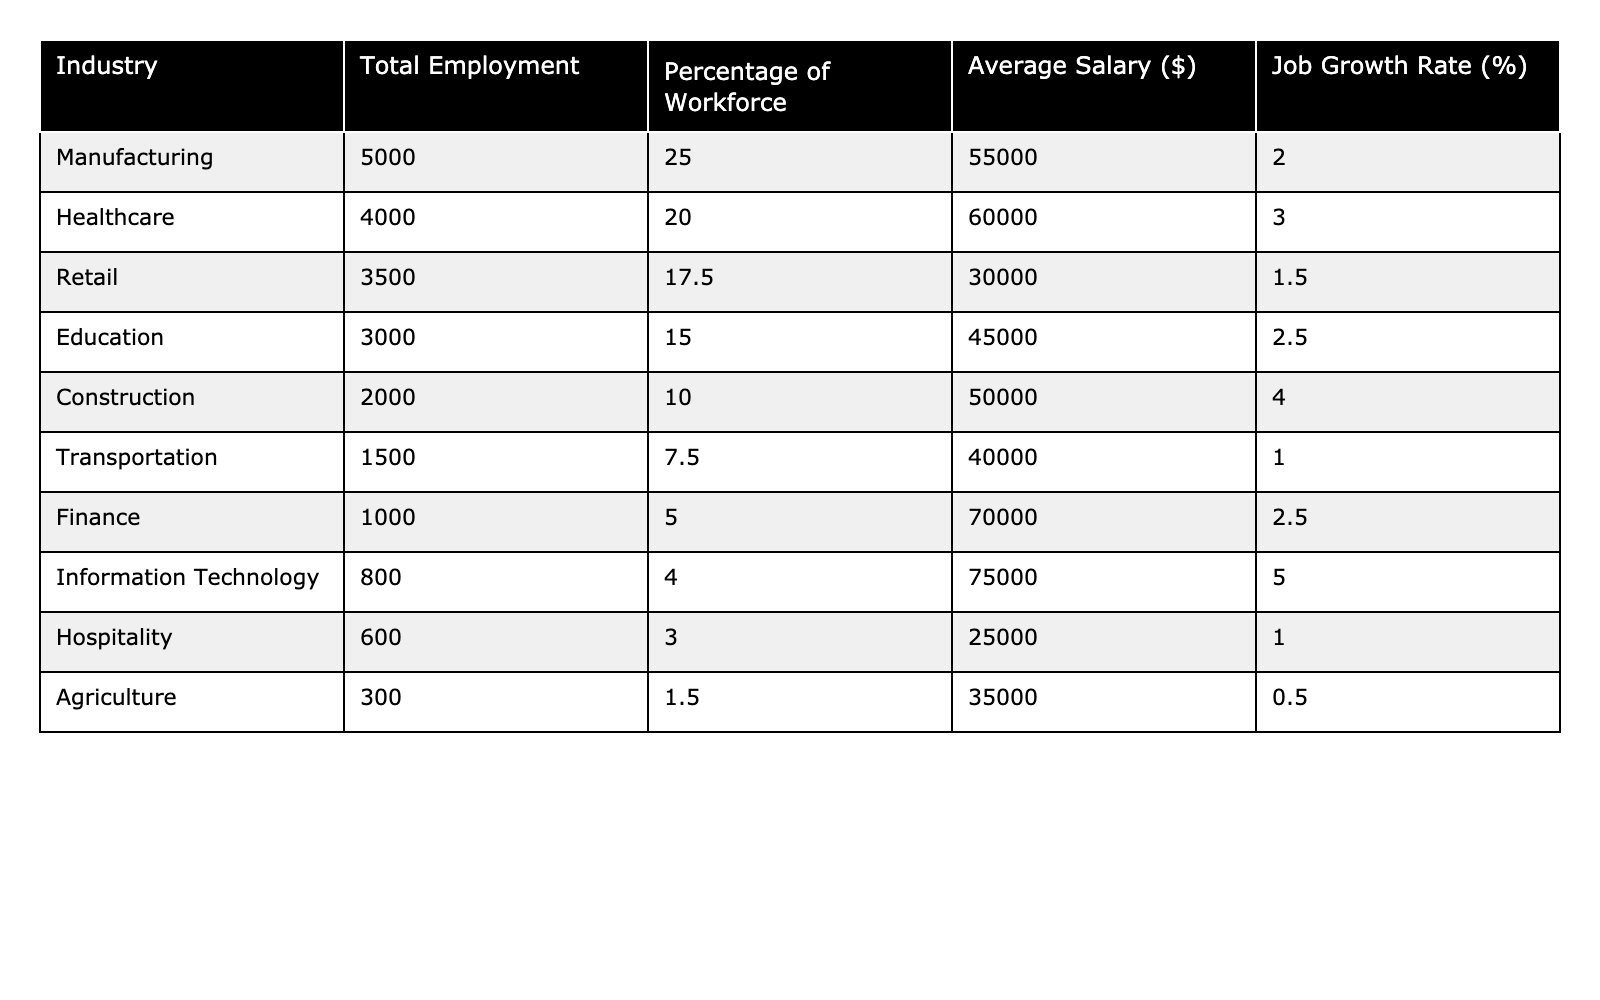What's the total employment in the Manufacturing industry? The table lists the Total Employment for the Manufacturing industry as 5,000.
Answer: 5000 Which industry has the highest average salary? The highest average salary in the table is $75,000, associated with the Information Technology industry.
Answer: Information Technology What percentage of the workforce is employed in Healthcare? The Percentage of Workforce in Healthcare is 20%.
Answer: 20% How many employees are working in Retail compared to Transportation? Retail has 3,500 employees and Transportation has 1,500 employees, so Retail has 2,000 more employees than Transportation (3,500 - 1,500 = 2,000).
Answer: 2000 more What is the total percentage of the workforce in Manufacturing and Construction? The percentages are 25% for Manufacturing and 10% for Construction. Adding them together: 25% + 10% = 35%.
Answer: 35% Is the job growth rate in Agriculture higher than in Hospitality? The job growth rate in Agriculture is 0.5%, while the rate in Hospitality is 1%. Since 0.5% is less than 1%, the statement is false.
Answer: No What is the average salary of the top three industries by employment? The top three industries by employment are Manufacturing (55,000), Healthcare (60,000), and Retail (30,000). The average is calculated as (55,000 + 60,000 + 30,000) / 3 = 48,333.
Answer: 48333 If you add the total employment in Agriculture and Hospitality, what do you get? Agriculture has 300 employees and Hospitality has 600 employees. Adding them gives 300 + 600 = 900.
Answer: 900 Which industry has the lowest job growth rate? Agriculture has the lowest job growth rate at 0.5%.
Answer: Agriculture Is the average salary in Finance greater than the average salary in Manufacturing? The average salary in Finance is $70,000, while in Manufacturing it is $55,000. Since 70,000 is greater than 55,000, the statement is true.
Answer: Yes 